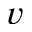<formula> <loc_0><loc_0><loc_500><loc_500>v</formula> 